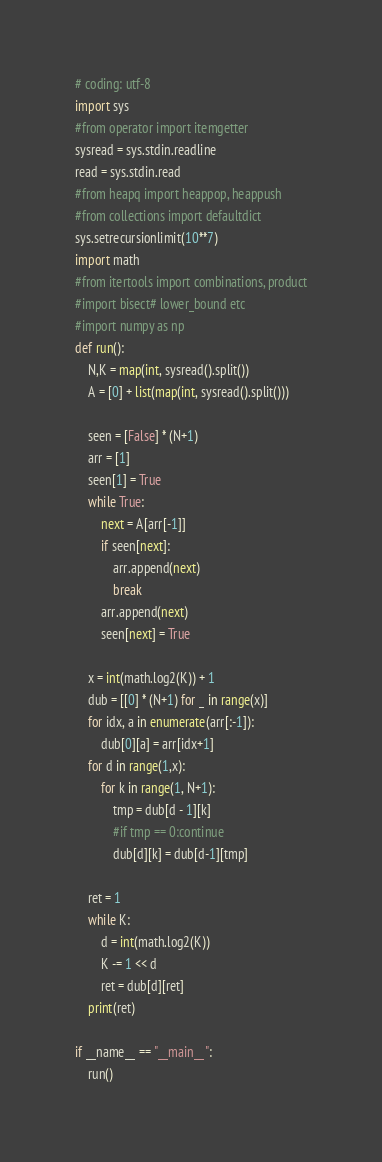<code> <loc_0><loc_0><loc_500><loc_500><_Python_># coding: utf-8
import sys
#from operator import itemgetter
sysread = sys.stdin.readline
read = sys.stdin.read
#from heapq import heappop, heappush
#from collections import defaultdict
sys.setrecursionlimit(10**7)
import math
#from itertools import combinations, product
#import bisect# lower_bound etc
#import numpy as np
def run():
    N,K = map(int, sysread().split())
    A = [0] + list(map(int, sysread().split()))

    seen = [False] * (N+1)
    arr = [1]
    seen[1] = True
    while True:
        next = A[arr[-1]]
        if seen[next]:
            arr.append(next)
            break
        arr.append(next)
        seen[next] = True

    x = int(math.log2(K)) + 1
    dub = [[0] * (N+1) for _ in range(x)]
    for idx, a in enumerate(arr[:-1]):
        dub[0][a] = arr[idx+1]
    for d in range(1,x):
        for k in range(1, N+1):
            tmp = dub[d - 1][k]
            #if tmp == 0:continue
            dub[d][k] = dub[d-1][tmp]

    ret = 1
    while K:
        d = int(math.log2(K))
        K -= 1 << d
        ret = dub[d][ret]
    print(ret)

if __name__ == "__main__":
    run()</code> 